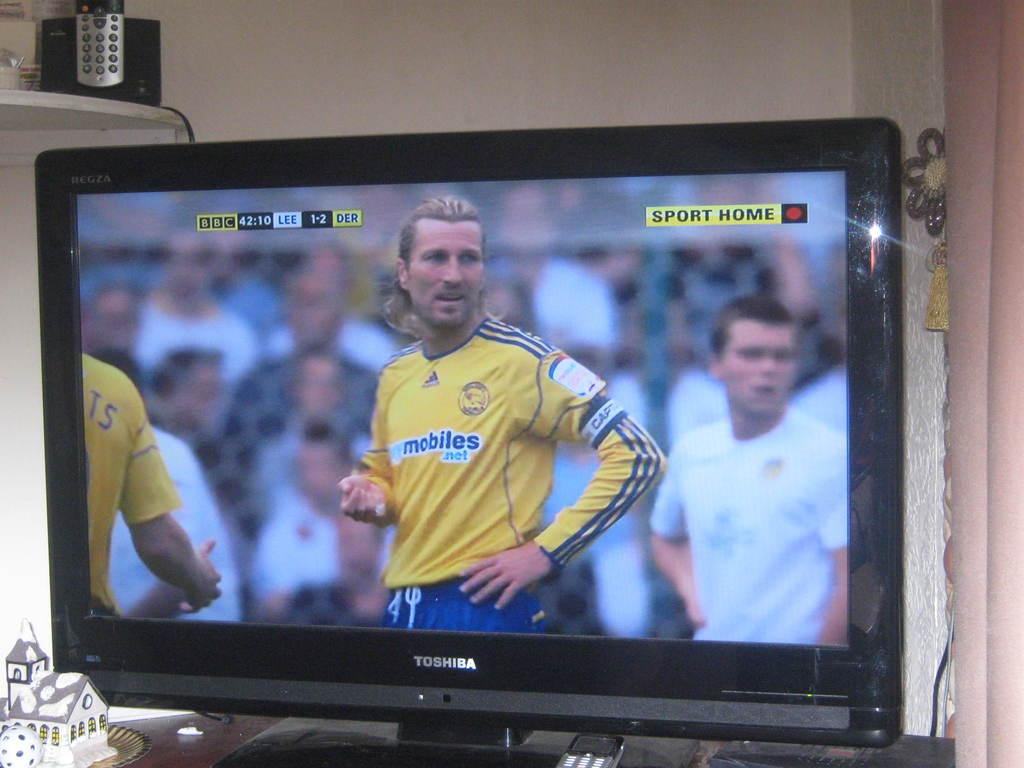<image>
Summarize the visual content of the image. TOSHIBA TELEVISION SHOWING A SOCCER MATCH ON THE BBC CHANNEL 